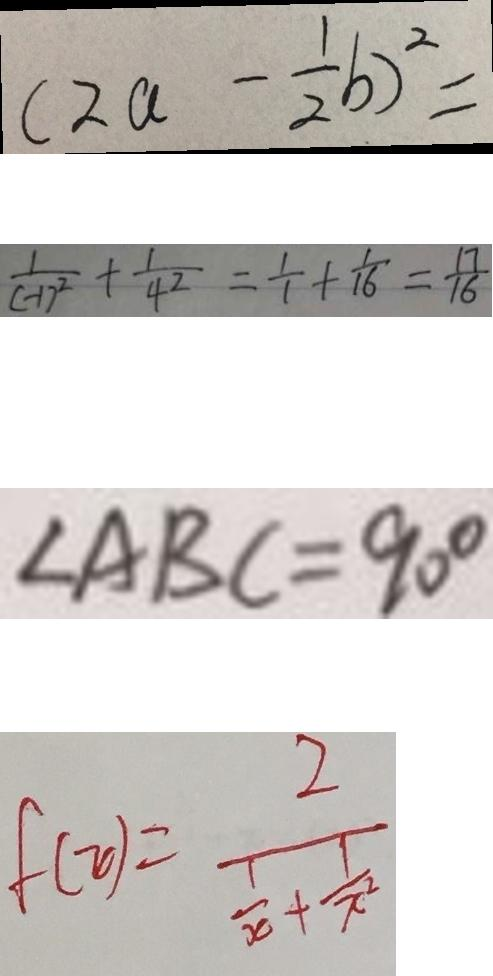<formula> <loc_0><loc_0><loc_500><loc_500>( 2 a - \frac { 1 } { 2 } b ) ^ { 2 } = 
 \frac { 1 } { ( - 1 ) ^ { 2 } } + \frac { 1 } { 4 ^ { 2 } } = \frac { 1 } { 1 } + \frac { 1 } { 1 6 } = \frac { 1 7 } { 1 6 } 
 \angle A B C = 9 0 ^ { \circ } 
 f ( x ) = \frac { 2 } { \frac { 1 } { x } + \frac { 1 } { x ^ { 2 } } }</formula> 